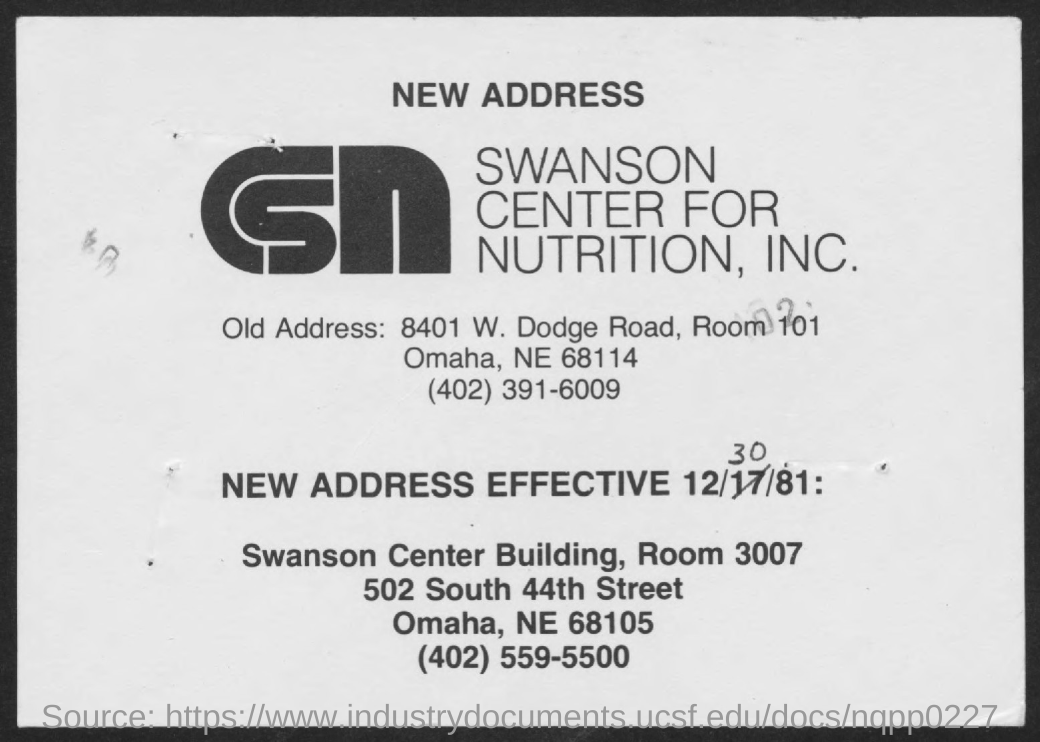Outline some significant characteristics in this image. The new address will become effective on December 30, 1981. 